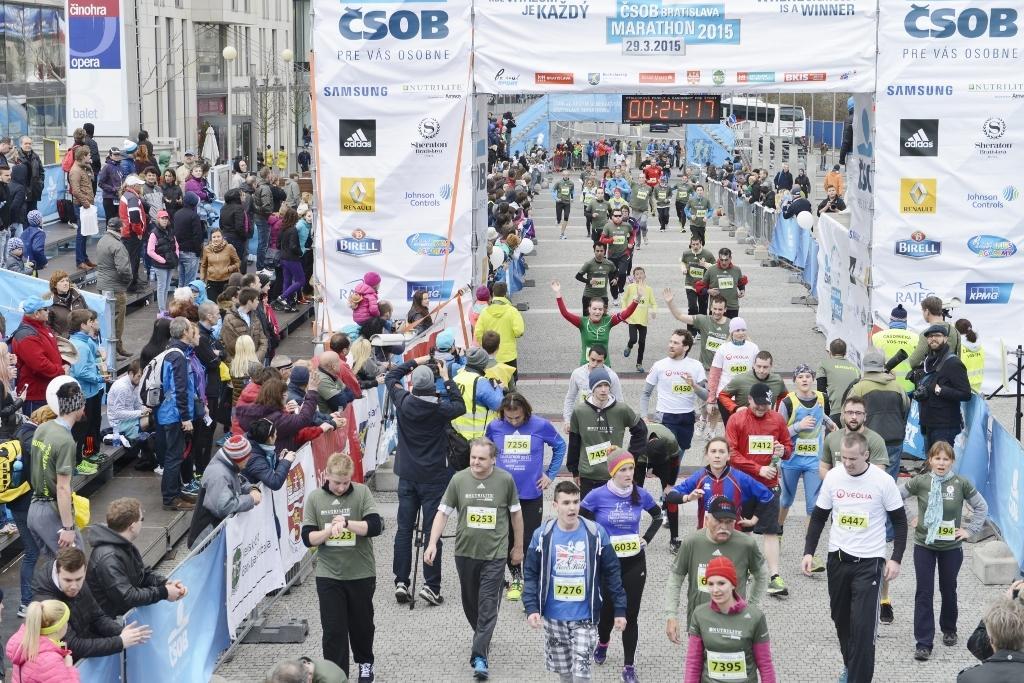Could you give a brief overview of what you see in this image? As we can see in the image there are few people walking here and there, banners, buildings, street lamps and in the background there is a bus. 